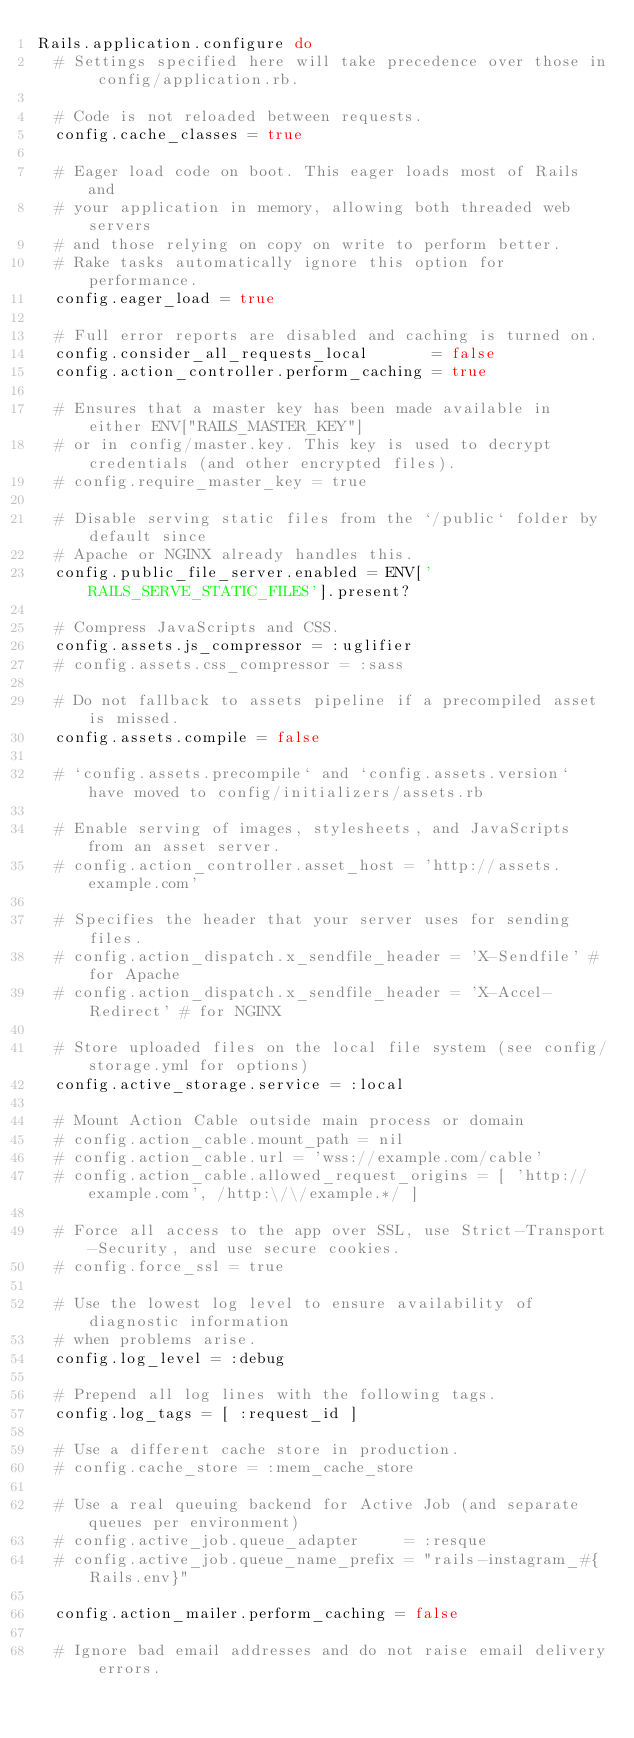<code> <loc_0><loc_0><loc_500><loc_500><_Ruby_>Rails.application.configure do
  # Settings specified here will take precedence over those in config/application.rb.

  # Code is not reloaded between requests.
  config.cache_classes = true

  # Eager load code on boot. This eager loads most of Rails and
  # your application in memory, allowing both threaded web servers
  # and those relying on copy on write to perform better.
  # Rake tasks automatically ignore this option for performance.
  config.eager_load = true

  # Full error reports are disabled and caching is turned on.
  config.consider_all_requests_local       = false
  config.action_controller.perform_caching = true

  # Ensures that a master key has been made available in either ENV["RAILS_MASTER_KEY"]
  # or in config/master.key. This key is used to decrypt credentials (and other encrypted files).
  # config.require_master_key = true

  # Disable serving static files from the `/public` folder by default since
  # Apache or NGINX already handles this.
  config.public_file_server.enabled = ENV['RAILS_SERVE_STATIC_FILES'].present?

  # Compress JavaScripts and CSS.
  config.assets.js_compressor = :uglifier
  # config.assets.css_compressor = :sass

  # Do not fallback to assets pipeline if a precompiled asset is missed.
  config.assets.compile = false

  # `config.assets.precompile` and `config.assets.version` have moved to config/initializers/assets.rb

  # Enable serving of images, stylesheets, and JavaScripts from an asset server.
  # config.action_controller.asset_host = 'http://assets.example.com'

  # Specifies the header that your server uses for sending files.
  # config.action_dispatch.x_sendfile_header = 'X-Sendfile' # for Apache
  # config.action_dispatch.x_sendfile_header = 'X-Accel-Redirect' # for NGINX

  # Store uploaded files on the local file system (see config/storage.yml for options)
  config.active_storage.service = :local

  # Mount Action Cable outside main process or domain
  # config.action_cable.mount_path = nil
  # config.action_cable.url = 'wss://example.com/cable'
  # config.action_cable.allowed_request_origins = [ 'http://example.com', /http:\/\/example.*/ ]

  # Force all access to the app over SSL, use Strict-Transport-Security, and use secure cookies.
  # config.force_ssl = true

  # Use the lowest log level to ensure availability of diagnostic information
  # when problems arise.
  config.log_level = :debug

  # Prepend all log lines with the following tags.
  config.log_tags = [ :request_id ]

  # Use a different cache store in production.
  # config.cache_store = :mem_cache_store

  # Use a real queuing backend for Active Job (and separate queues per environment)
  # config.active_job.queue_adapter     = :resque
  # config.active_job.queue_name_prefix = "rails-instagram_#{Rails.env}"

  config.action_mailer.perform_caching = false

  # Ignore bad email addresses and do not raise email delivery errors.</code> 